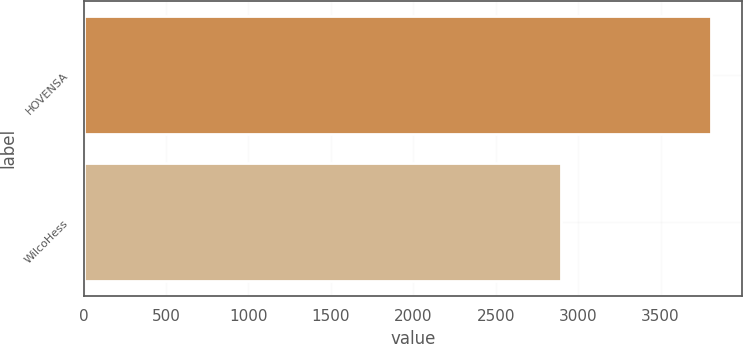Convert chart to OTSL. <chart><loc_0><loc_0><loc_500><loc_500><bar_chart><fcel>HOVENSA<fcel>WilcoHess<nl><fcel>3806<fcel>2898<nl></chart> 